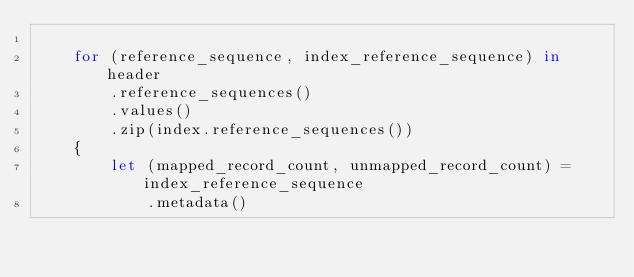<code> <loc_0><loc_0><loc_500><loc_500><_Rust_>
    for (reference_sequence, index_reference_sequence) in header
        .reference_sequences()
        .values()
        .zip(index.reference_sequences())
    {
        let (mapped_record_count, unmapped_record_count) = index_reference_sequence
            .metadata()</code> 